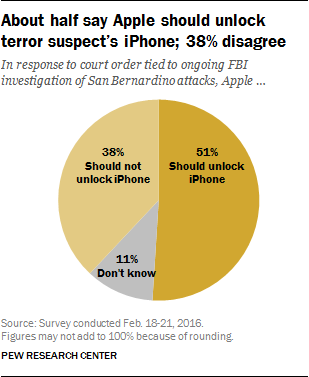What is this chart about? This image features a chart from a Pew Research Center survey conducted in February 2016. It indicates public opinion on whether Apple should unlock the iPhone of a terror suspect in relation to the San Bernardino attacks and an ongoing FBI investigation. 